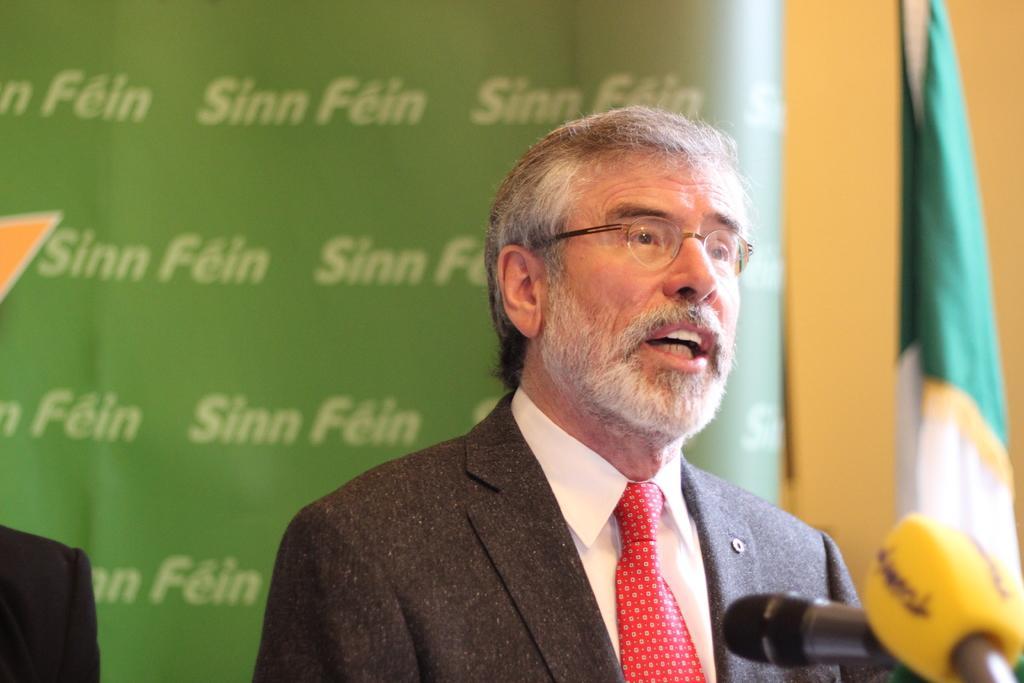Describe this image in one or two sentences. In the picture I can see man is wearing spectacles, a red color tie, a shirt and a coat. Here I can see microphones. In the background I can see a flag and a banner which has something written on it. The background of the image is blurred. 